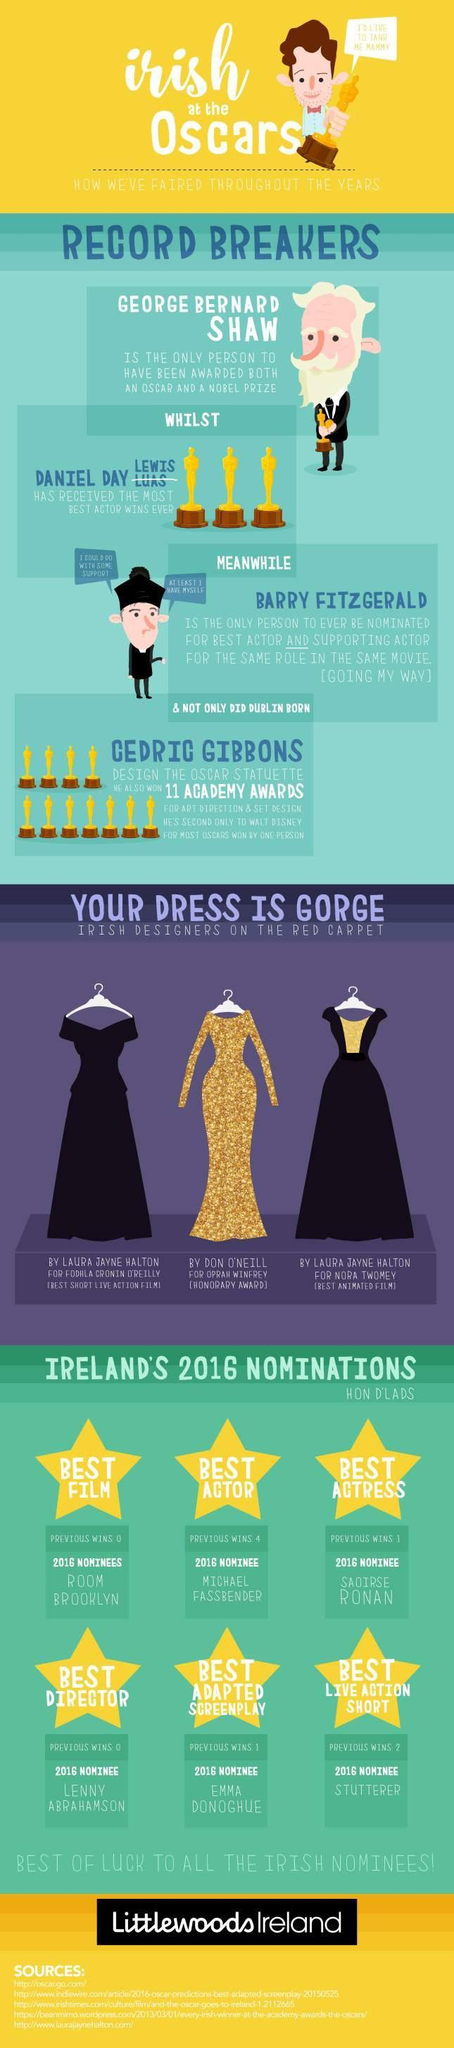How many sources are listed at the bottom?
Answer the question with a short phrase. 5 